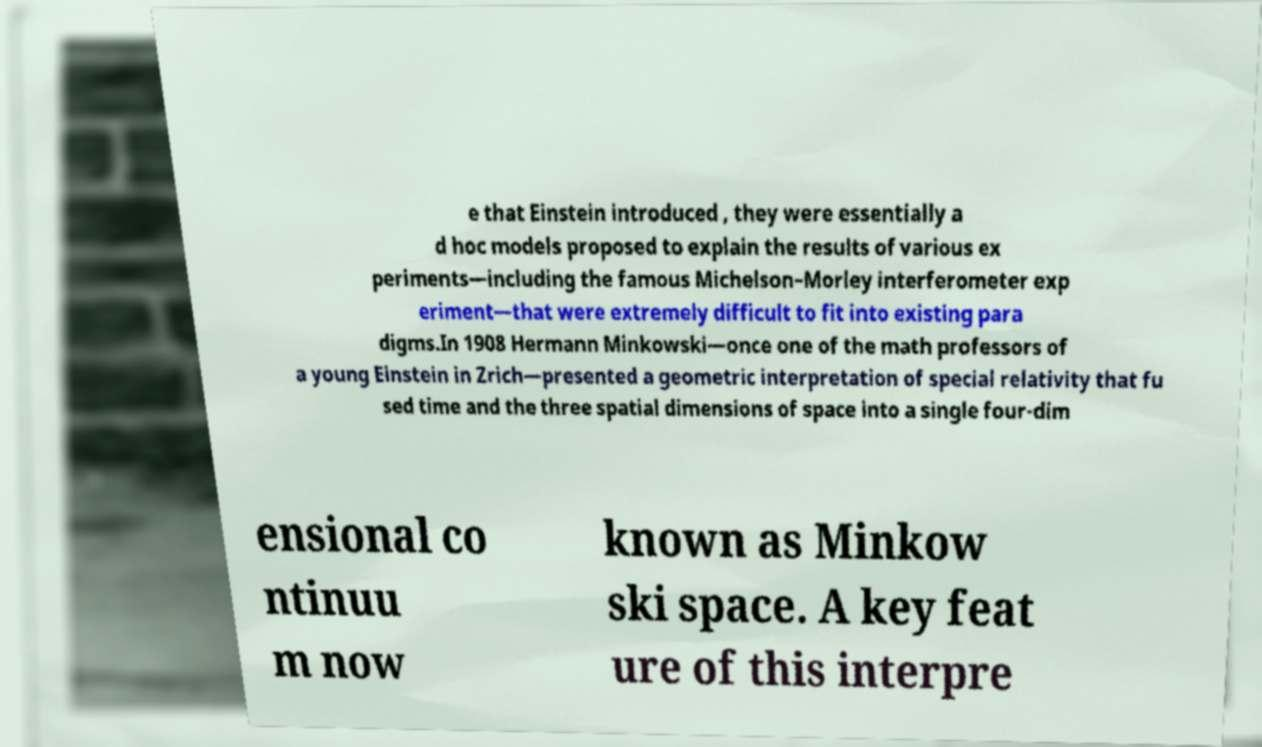There's text embedded in this image that I need extracted. Can you transcribe it verbatim? e that Einstein introduced , they were essentially a d hoc models proposed to explain the results of various ex periments—including the famous Michelson–Morley interferometer exp eriment—that were extremely difficult to fit into existing para digms.In 1908 Hermann Minkowski—once one of the math professors of a young Einstein in Zrich—presented a geometric interpretation of special relativity that fu sed time and the three spatial dimensions of space into a single four-dim ensional co ntinuu m now known as Minkow ski space. A key feat ure of this interpre 